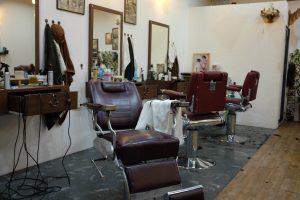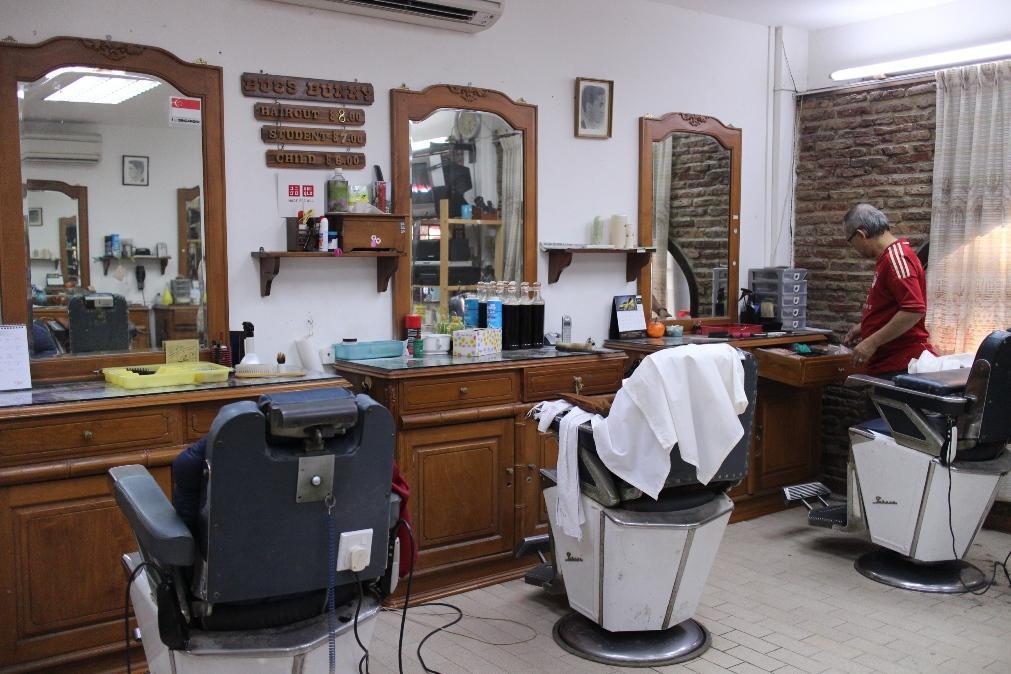The first image is the image on the left, the second image is the image on the right. Given the left and right images, does the statement "In at least one of the images within a set, the barber is only cutting one person's hair, in the left most chair." hold true? Answer yes or no. No. The first image is the image on the left, the second image is the image on the right. Evaluate the accuracy of this statement regarding the images: "There is at least one male barber in a black shirt cutting the hair of a man in a cape sitting in the barber chair.". Is it true? Answer yes or no. No. 